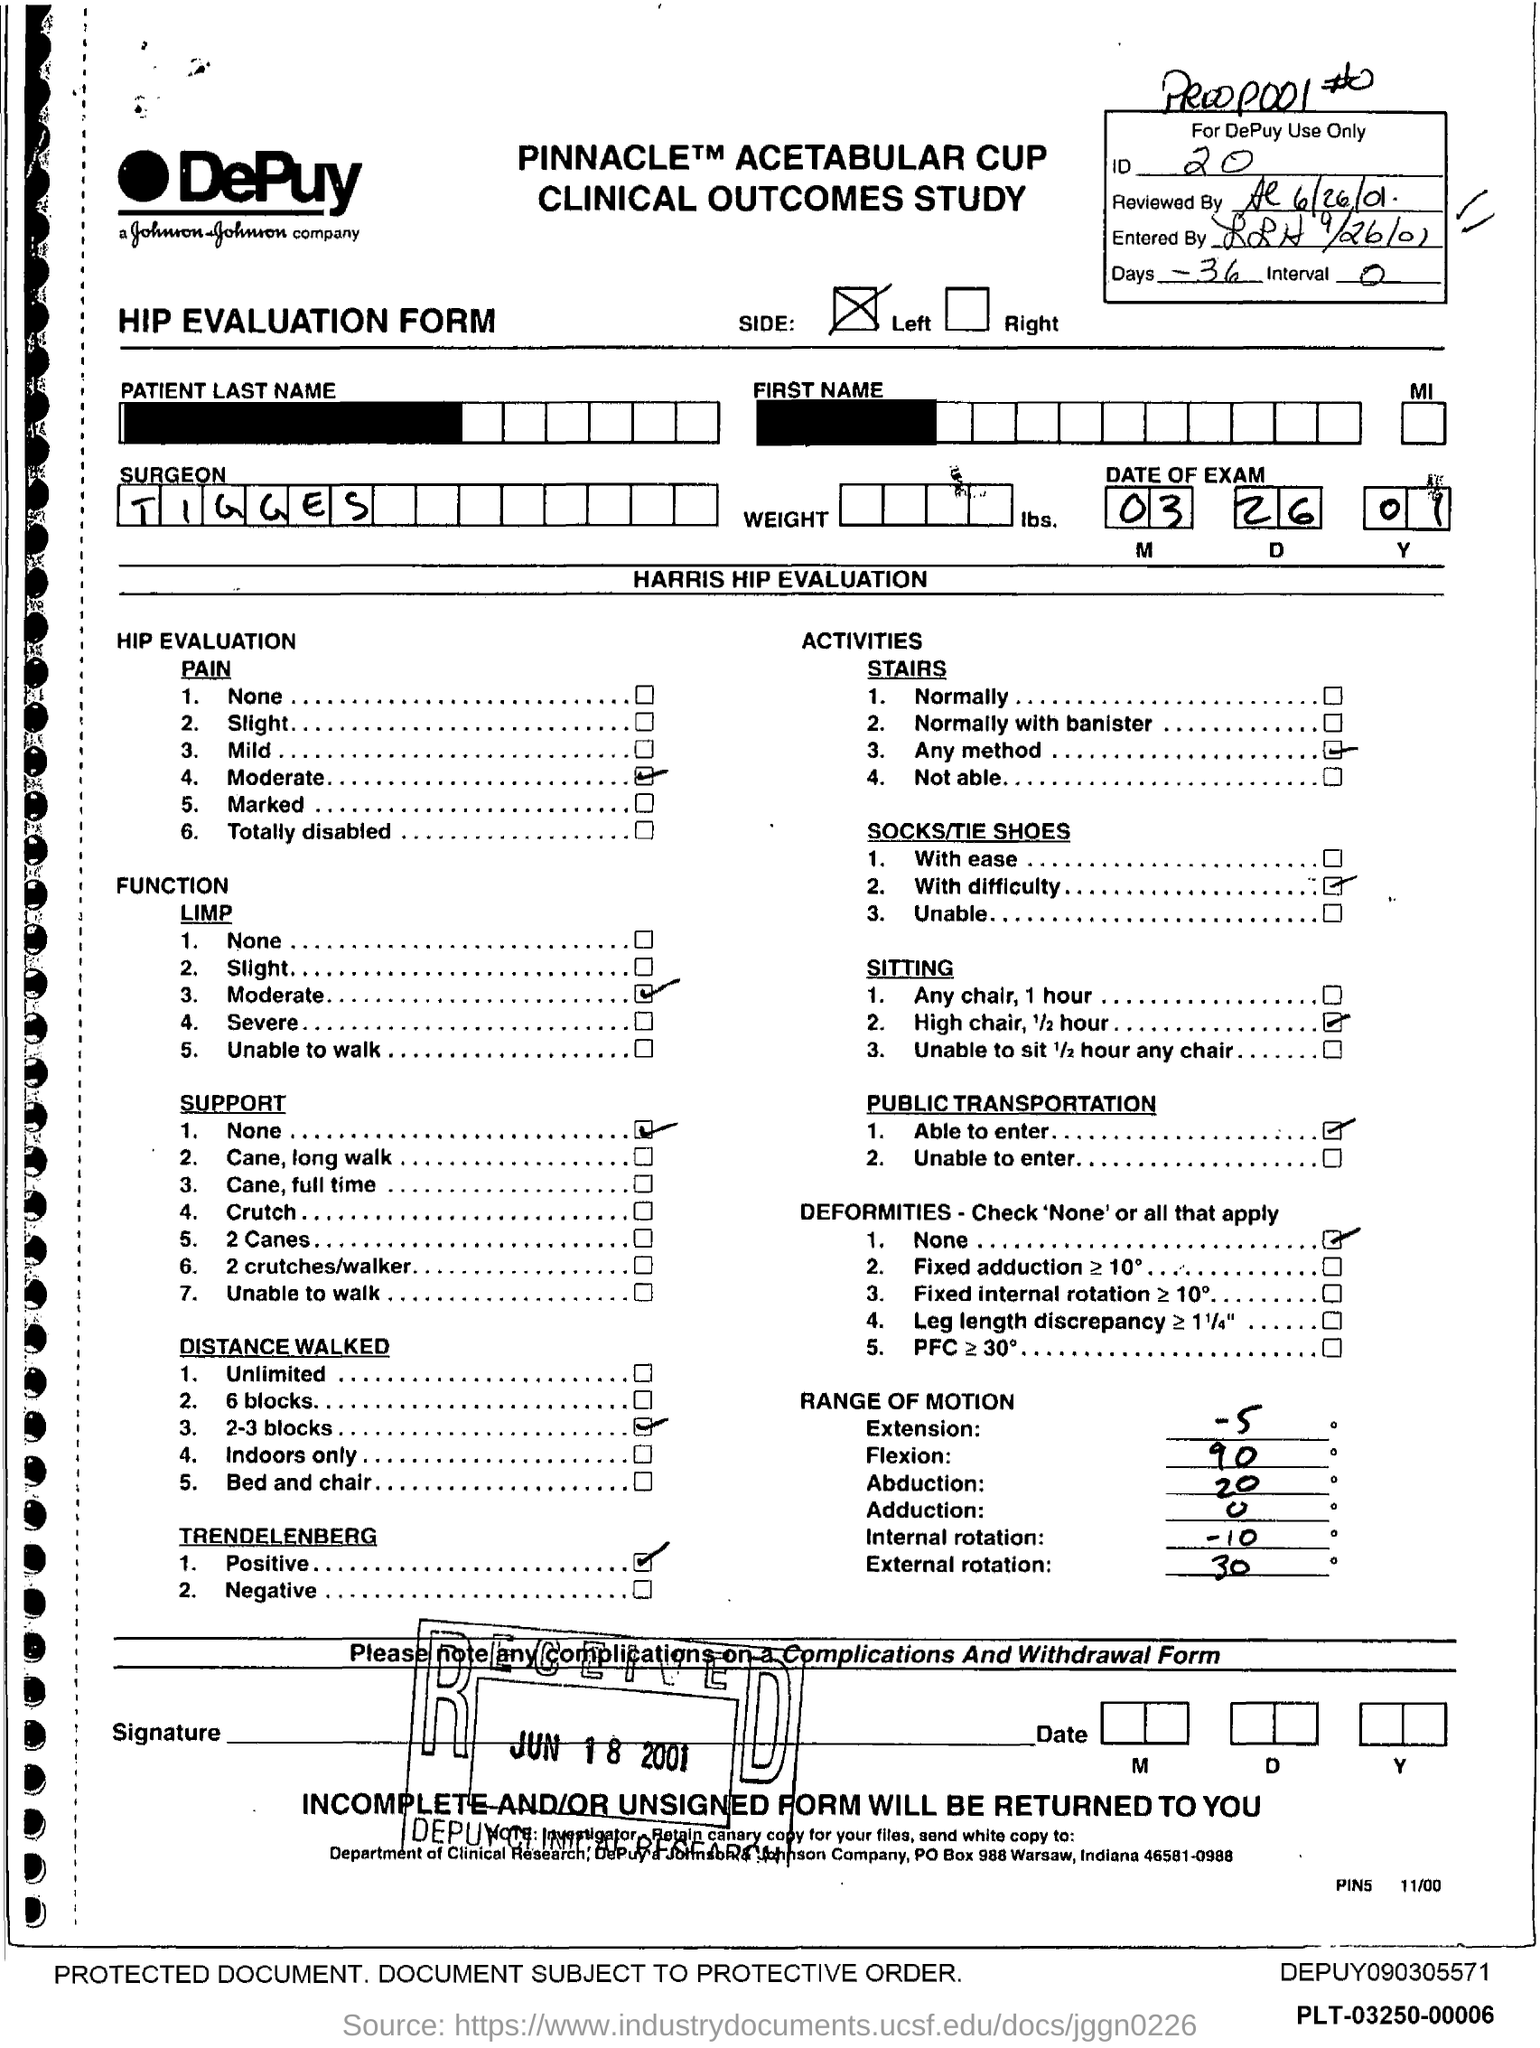Highlight a few significant elements in this photo. The ID mentioned in the form is 20. The surgeon mentioned in the form is TIGGES. There are 36 days given in the form. The received date of the form is June 18, 2001. The date of the exam specified in the form is March 26, 2001. 